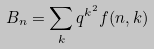Convert formula to latex. <formula><loc_0><loc_0><loc_500><loc_500>B _ { n } = \sum _ { k } q ^ { k ^ { 2 } } f ( n , k )</formula> 